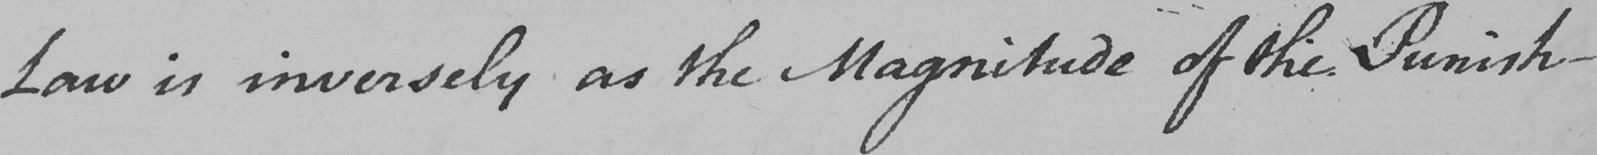Can you read and transcribe this handwriting? Law is inversely as the Magnitude of the Punish- 